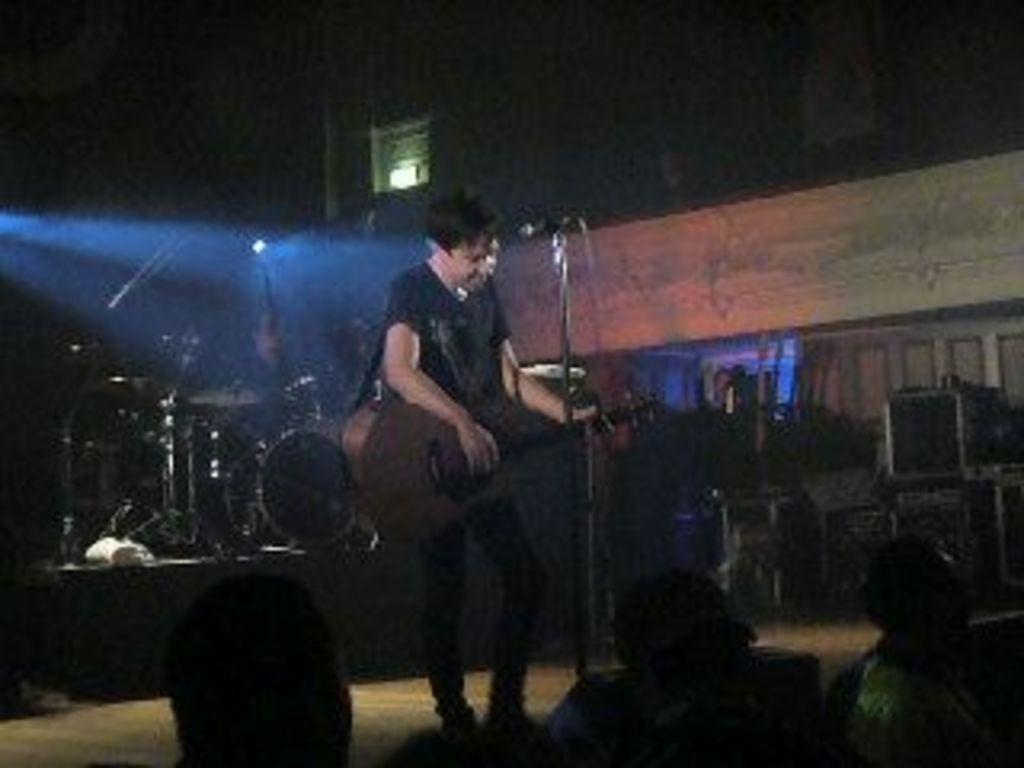What is the man in the image doing? The man is playing a guitar in the image. What instrument is visible in the image besides the guitar? There is a microphone and drums in the image. Who might be listening to the man playing the guitar? There are audience members seated in the image, who might be listening to the man playing the guitar. What can be seen in the background of the image? There is a light visible in the background of the image. What type of crack is visible on the guitar in the image? There is no crack visible on the guitar in the image. Is there a notebook present in the image? No, there is no notebook present in the image. 